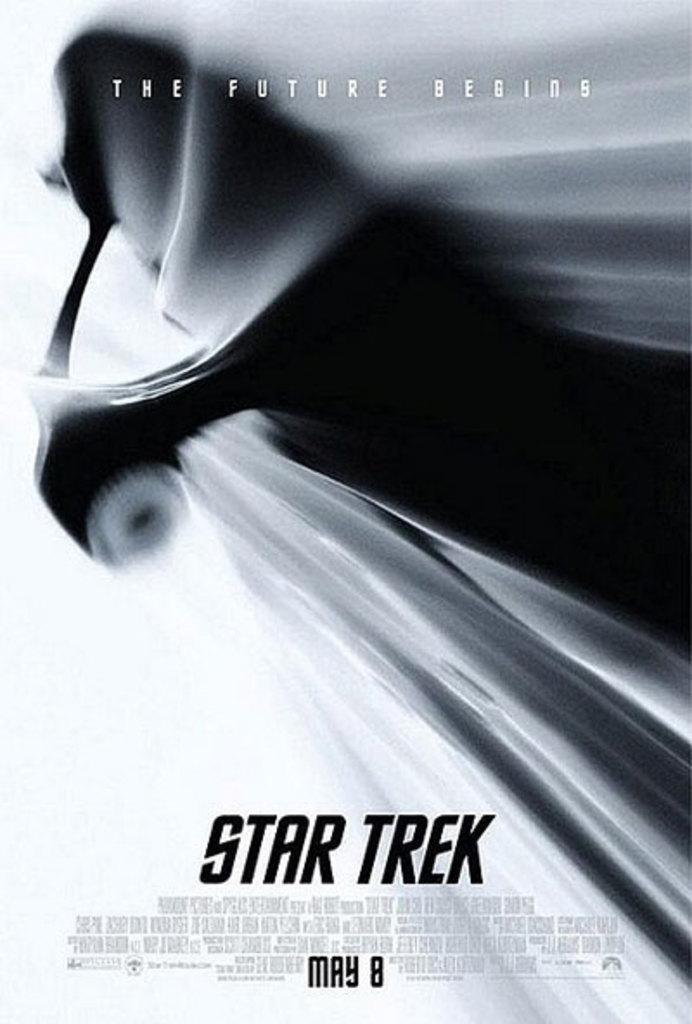Could you give a brief overview of what you see in this image? In the image we can see a poster of black, gray and white in color, and there is an edited text on the poster. 